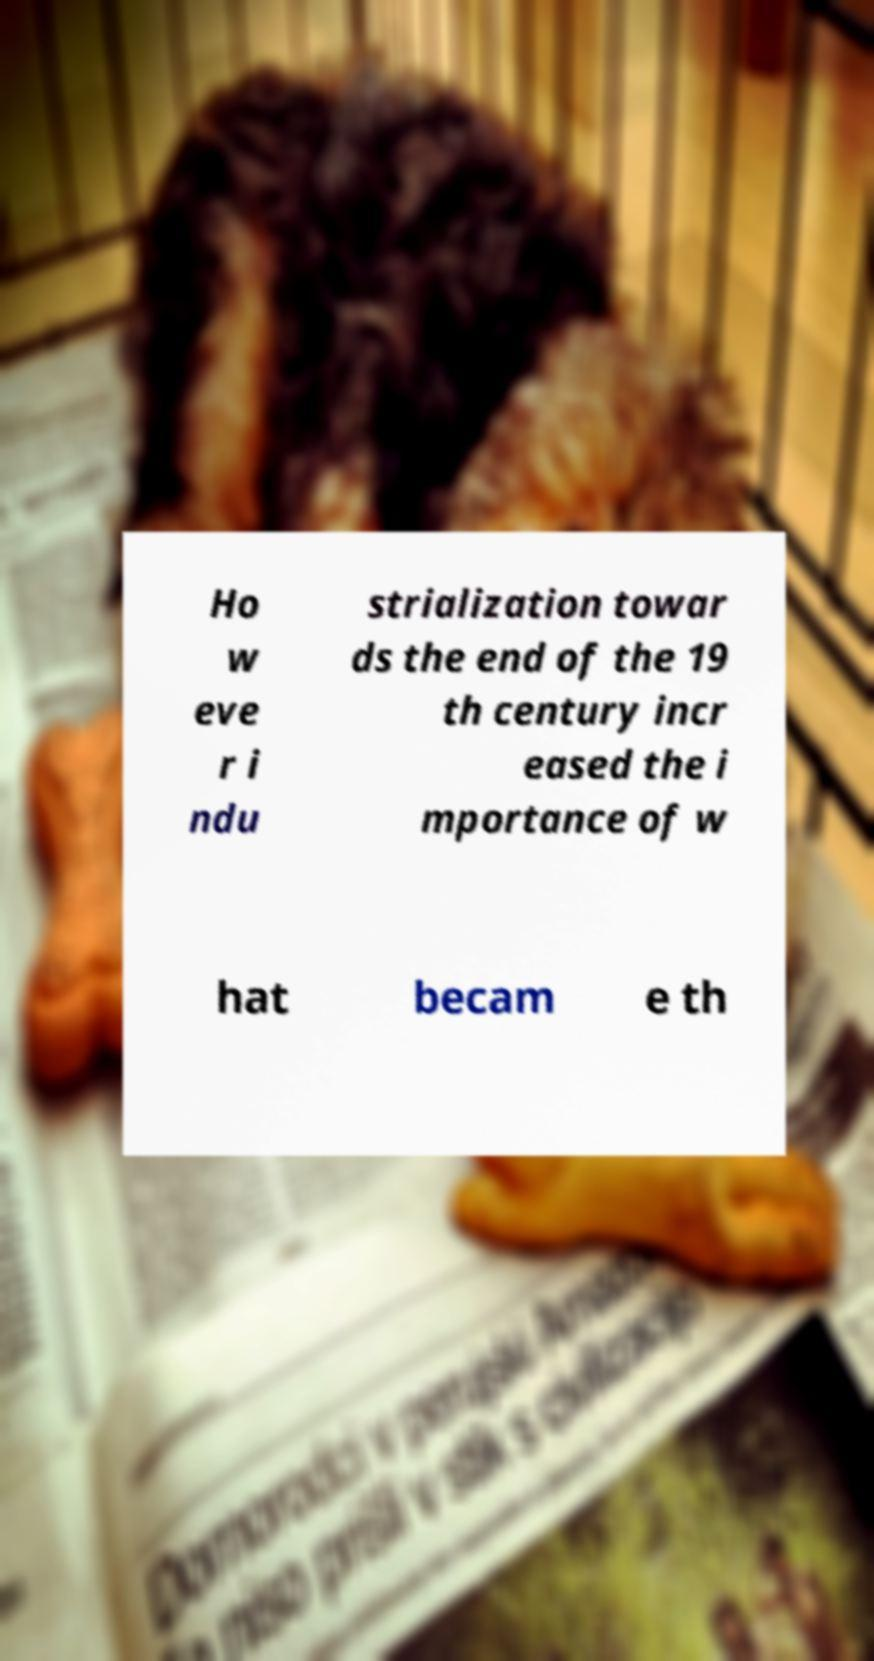Can you accurately transcribe the text from the provided image for me? Ho w eve r i ndu strialization towar ds the end of the 19 th century incr eased the i mportance of w hat becam e th 